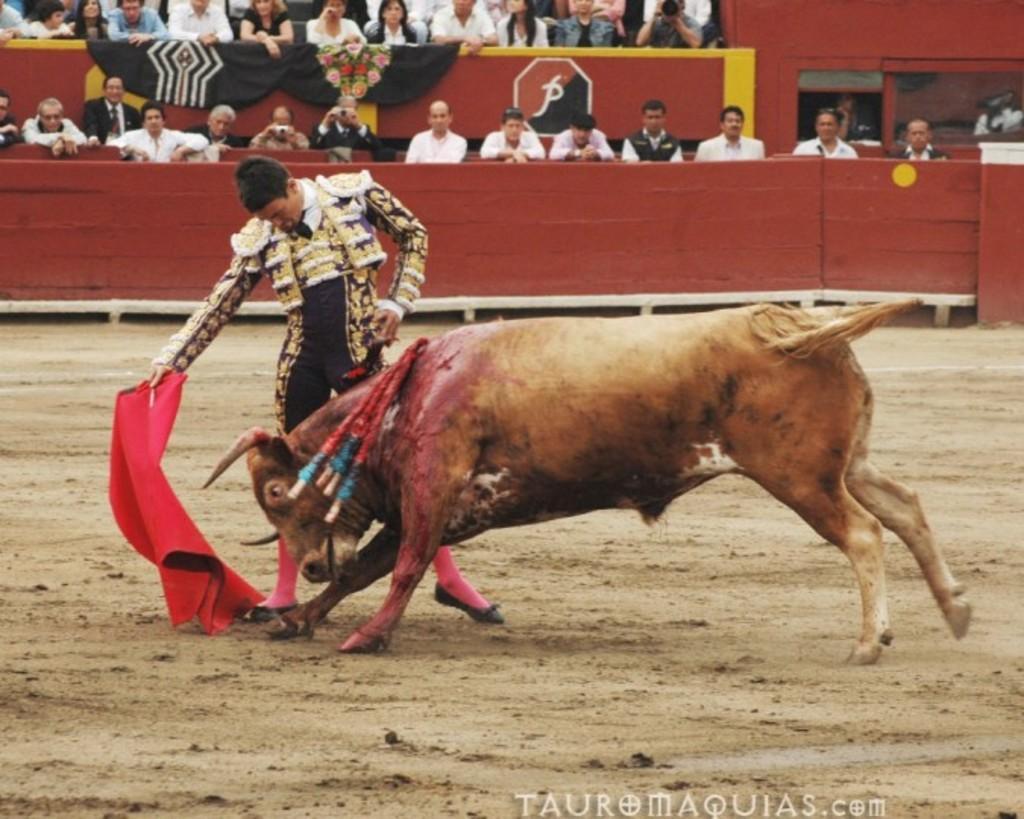Could you give a brief overview of what you see in this image? In this picture we can see one person is standing on a ground and playing with the bull, back side so many people sitting and watching. 